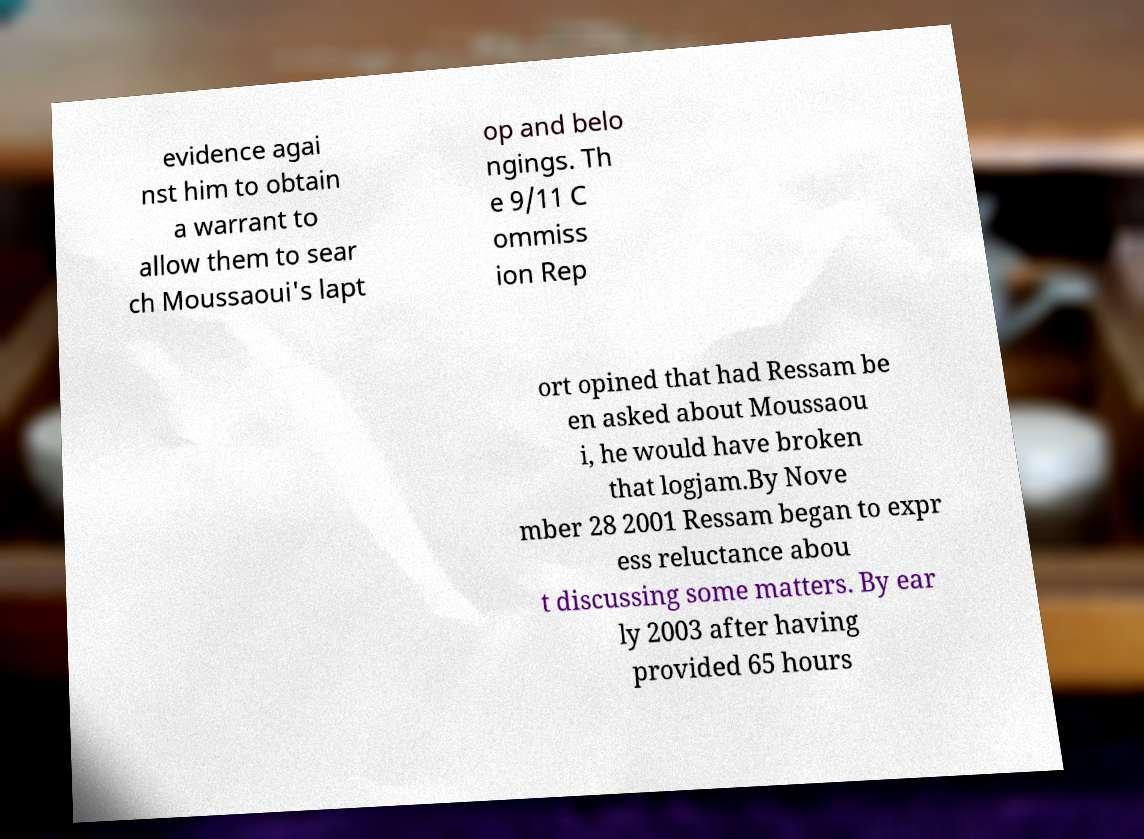Can you read and provide the text displayed in the image?This photo seems to have some interesting text. Can you extract and type it out for me? evidence agai nst him to obtain a warrant to allow them to sear ch Moussaoui's lapt op and belo ngings. Th e 9/11 C ommiss ion Rep ort opined that had Ressam be en asked about Moussaou i, he would have broken that logjam.By Nove mber 28 2001 Ressam began to expr ess reluctance abou t discussing some matters. By ear ly 2003 after having provided 65 hours 